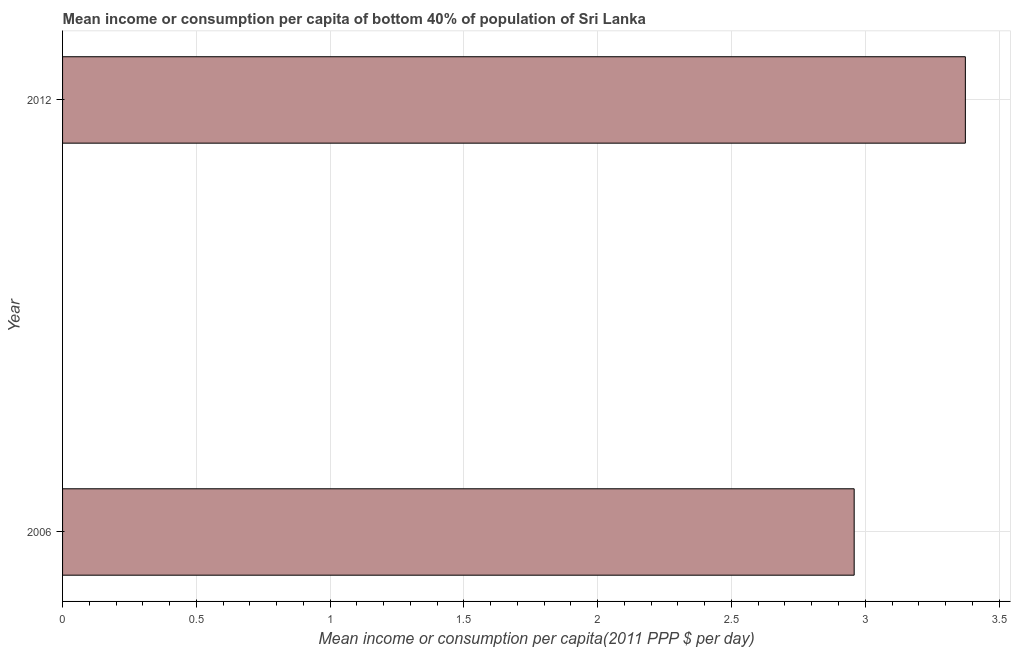Does the graph contain any zero values?
Your response must be concise. No. Does the graph contain grids?
Your answer should be compact. Yes. What is the title of the graph?
Ensure brevity in your answer.  Mean income or consumption per capita of bottom 40% of population of Sri Lanka. What is the label or title of the X-axis?
Provide a succinct answer. Mean income or consumption per capita(2011 PPP $ per day). What is the mean income or consumption in 2012?
Ensure brevity in your answer.  3.37. Across all years, what is the maximum mean income or consumption?
Your answer should be compact. 3.37. Across all years, what is the minimum mean income or consumption?
Ensure brevity in your answer.  2.96. What is the sum of the mean income or consumption?
Make the answer very short. 6.33. What is the difference between the mean income or consumption in 2006 and 2012?
Offer a terse response. -0.42. What is the average mean income or consumption per year?
Ensure brevity in your answer.  3.17. What is the median mean income or consumption?
Provide a succinct answer. 3.17. Do a majority of the years between 2006 and 2012 (inclusive) have mean income or consumption greater than 2.8 $?
Offer a terse response. Yes. What is the ratio of the mean income or consumption in 2006 to that in 2012?
Keep it short and to the point. 0.88. In how many years, is the mean income or consumption greater than the average mean income or consumption taken over all years?
Offer a terse response. 1. How many bars are there?
Keep it short and to the point. 2. How many years are there in the graph?
Your answer should be very brief. 2. What is the Mean income or consumption per capita(2011 PPP $ per day) of 2006?
Make the answer very short. 2.96. What is the Mean income or consumption per capita(2011 PPP $ per day) of 2012?
Keep it short and to the point. 3.37. What is the difference between the Mean income or consumption per capita(2011 PPP $ per day) in 2006 and 2012?
Provide a short and direct response. -0.42. What is the ratio of the Mean income or consumption per capita(2011 PPP $ per day) in 2006 to that in 2012?
Give a very brief answer. 0.88. 